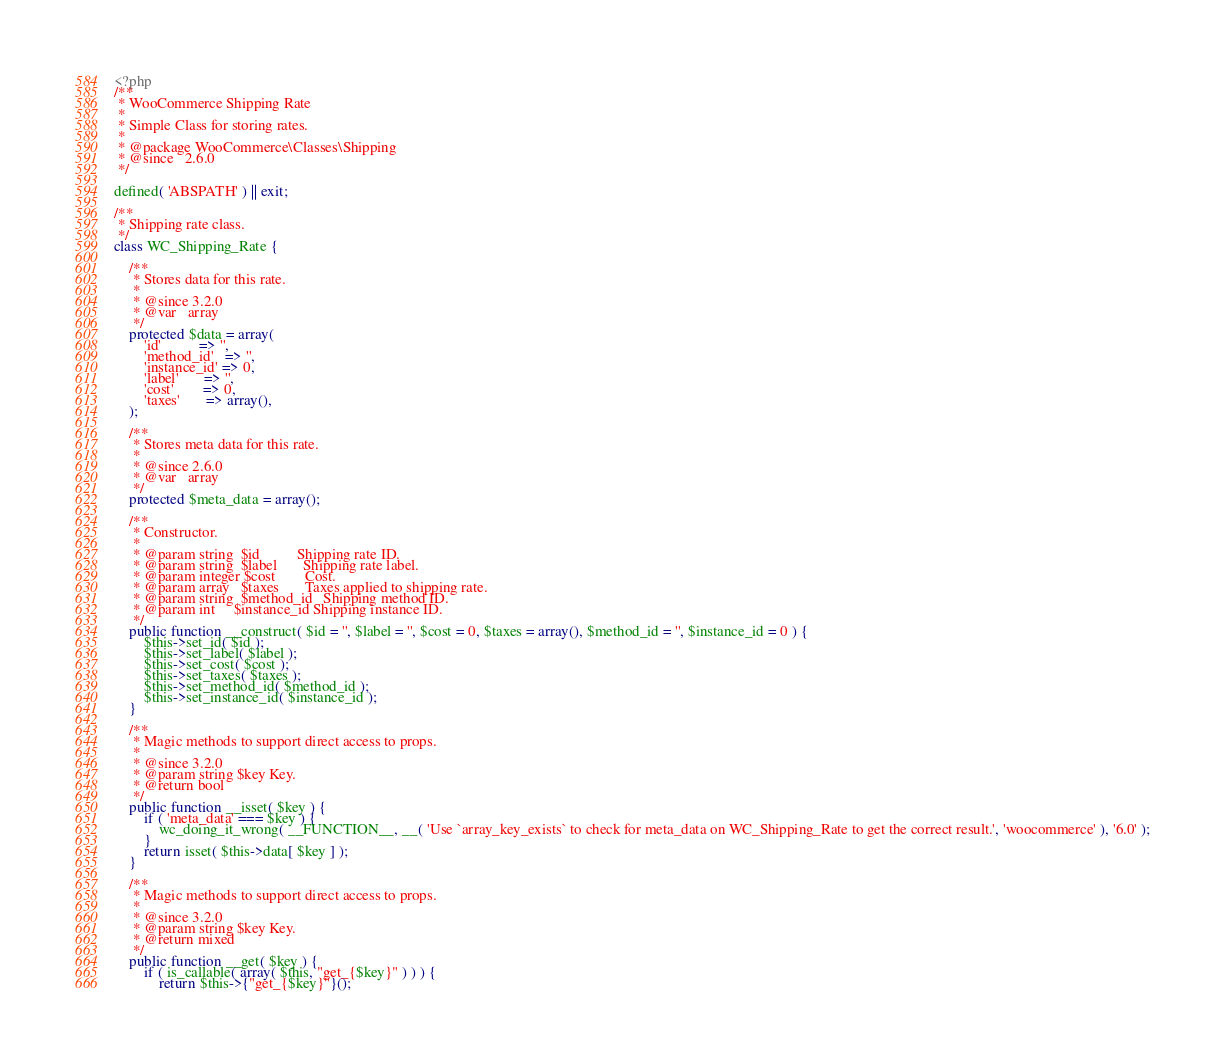Convert code to text. <code><loc_0><loc_0><loc_500><loc_500><_PHP_><?php
/**
 * WooCommerce Shipping Rate
 *
 * Simple Class for storing rates.
 *
 * @package WooCommerce\Classes\Shipping
 * @since   2.6.0
 */

defined( 'ABSPATH' ) || exit;

/**
 * Shipping rate class.
 */
class WC_Shipping_Rate {

	/**
	 * Stores data for this rate.
	 *
	 * @since 3.2.0
	 * @var   array
	 */
	protected $data = array(
		'id'          => '',
		'method_id'   => '',
		'instance_id' => 0,
		'label'       => '',
		'cost'        => 0,
		'taxes'       => array(),
	);

	/**
	 * Stores meta data for this rate.
	 *
	 * @since 2.6.0
	 * @var   array
	 */
	protected $meta_data = array();

	/**
	 * Constructor.
	 *
	 * @param string  $id          Shipping rate ID.
	 * @param string  $label       Shipping rate label.
	 * @param integer $cost        Cost.
	 * @param array   $taxes       Taxes applied to shipping rate.
	 * @param string  $method_id   Shipping method ID.
	 * @param int     $instance_id Shipping instance ID.
	 */
	public function __construct( $id = '', $label = '', $cost = 0, $taxes = array(), $method_id = '', $instance_id = 0 ) {
		$this->set_id( $id );
		$this->set_label( $label );
		$this->set_cost( $cost );
		$this->set_taxes( $taxes );
		$this->set_method_id( $method_id );
		$this->set_instance_id( $instance_id );
	}

	/**
	 * Magic methods to support direct access to props.
	 *
	 * @since 3.2.0
	 * @param string $key Key.
	 * @return bool
	 */
	public function __isset( $key ) {
		if ( 'meta_data' === $key ) {
			wc_doing_it_wrong( __FUNCTION__, __( 'Use `array_key_exists` to check for meta_data on WC_Shipping_Rate to get the correct result.', 'woocommerce' ), '6.0' );
		}
		return isset( $this->data[ $key ] );
	}

	/**
	 * Magic methods to support direct access to props.
	 *
	 * @since 3.2.0
	 * @param string $key Key.
	 * @return mixed
	 */
	public function __get( $key ) {
		if ( is_callable( array( $this, "get_{$key}" ) ) ) {
			return $this->{"get_{$key}"}();</code> 